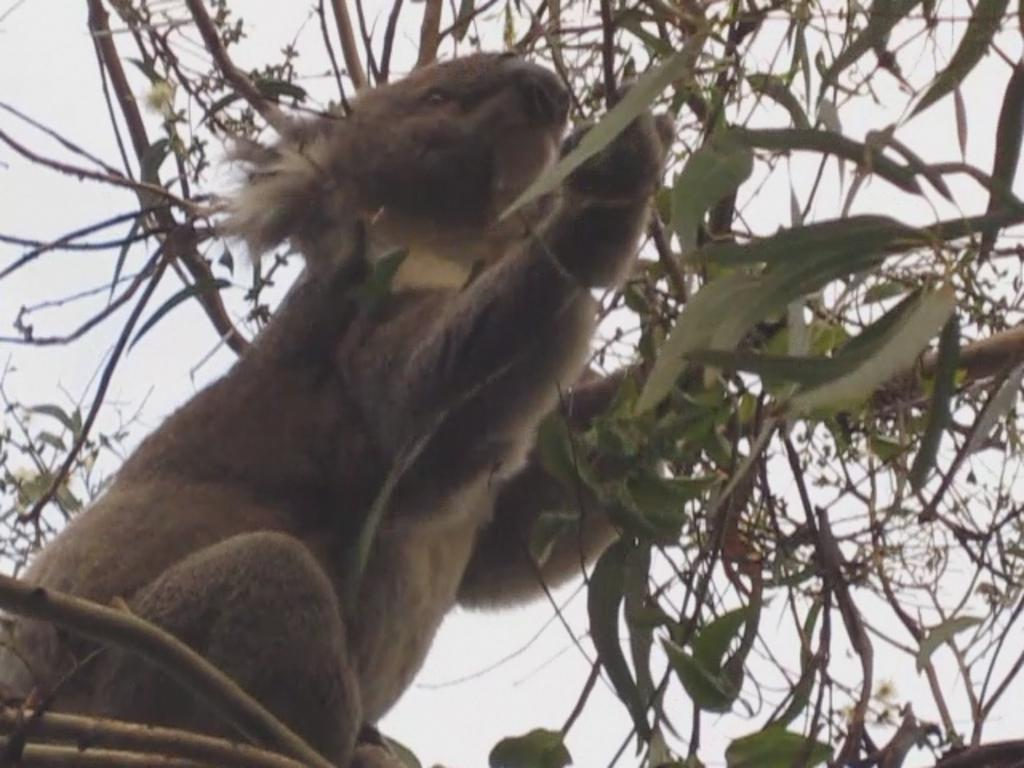What is present in the image that is a part of nature? There is a tree in the image. What is located above the tree in the image? There is an animal above the tree in the image. What can be seen in the background of the image? The sky is visible behind the tree in the image. What does the writer smell in the image? There is no writer present in the image, so it is not possible to determine what they might smell. 